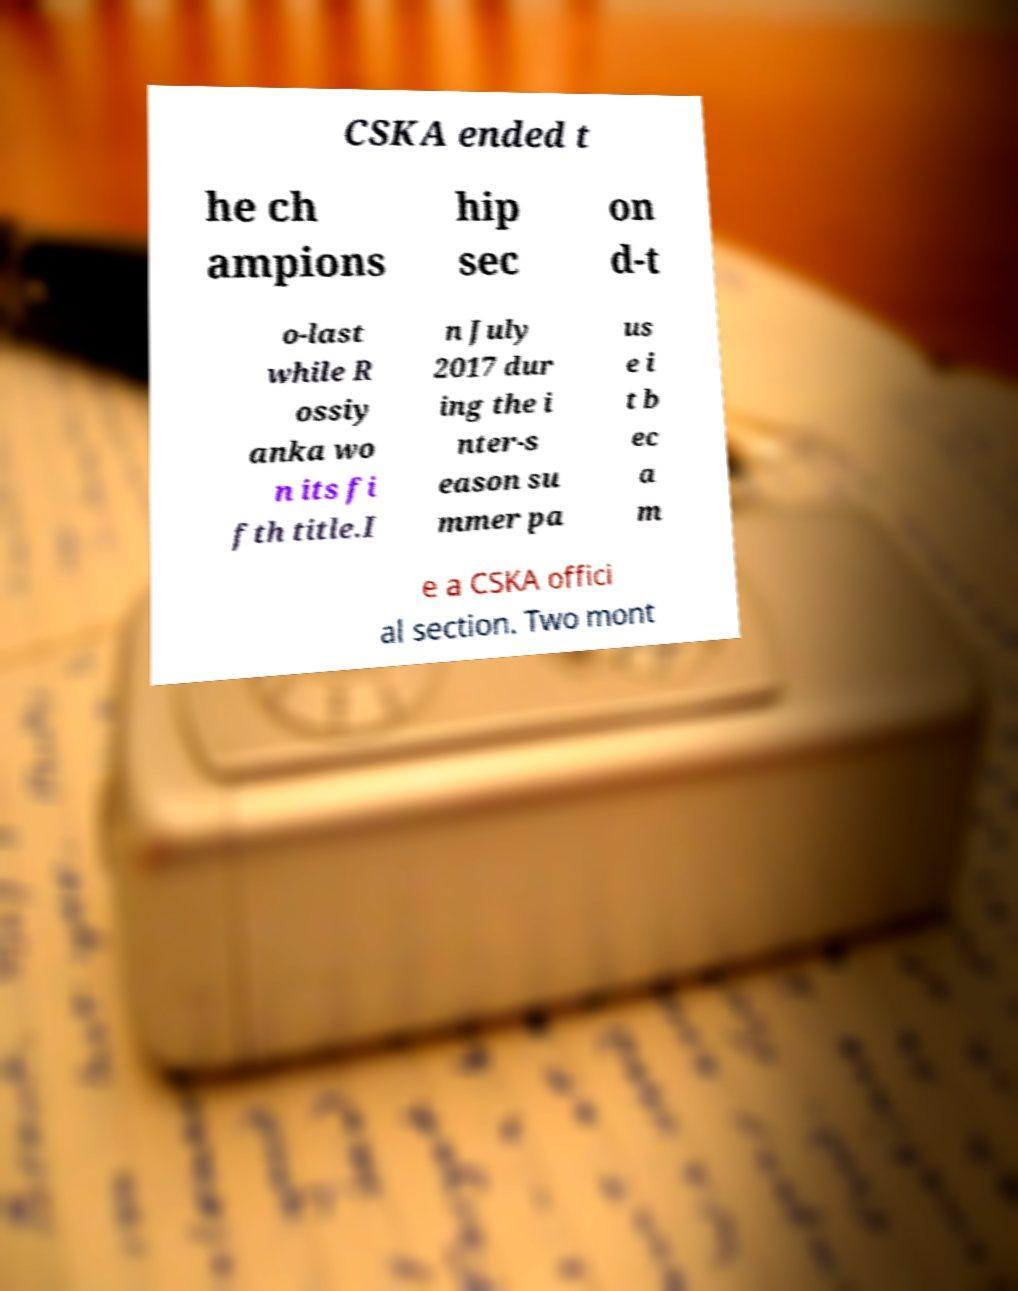I need the written content from this picture converted into text. Can you do that? CSKA ended t he ch ampions hip sec on d-t o-last while R ossiy anka wo n its fi fth title.I n July 2017 dur ing the i nter-s eason su mmer pa us e i t b ec a m e a CSKA offici al section. Two mont 